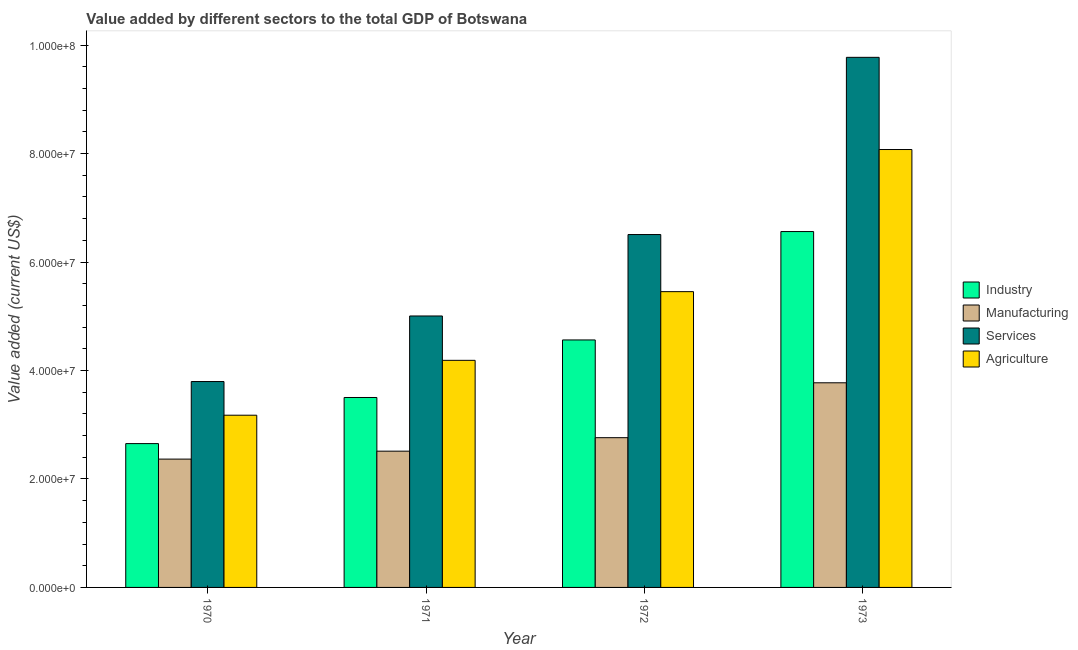How many different coloured bars are there?
Make the answer very short. 4. Are the number of bars on each tick of the X-axis equal?
Give a very brief answer. Yes. What is the label of the 2nd group of bars from the left?
Offer a terse response. 1971. What is the value added by industrial sector in 1972?
Offer a very short reply. 4.56e+07. Across all years, what is the maximum value added by services sector?
Make the answer very short. 9.78e+07. Across all years, what is the minimum value added by services sector?
Your answer should be very brief. 3.80e+07. In which year was the value added by agricultural sector minimum?
Give a very brief answer. 1970. What is the total value added by manufacturing sector in the graph?
Your response must be concise. 1.14e+08. What is the difference between the value added by manufacturing sector in 1971 and that in 1972?
Provide a succinct answer. -2.49e+06. What is the difference between the value added by industrial sector in 1971 and the value added by services sector in 1973?
Ensure brevity in your answer.  -3.06e+07. What is the average value added by agricultural sector per year?
Your answer should be very brief. 5.22e+07. What is the ratio of the value added by agricultural sector in 1971 to that in 1973?
Provide a succinct answer. 0.52. Is the difference between the value added by manufacturing sector in 1972 and 1973 greater than the difference between the value added by services sector in 1972 and 1973?
Your answer should be very brief. No. What is the difference between the highest and the second highest value added by manufacturing sector?
Your answer should be compact. 1.01e+07. What is the difference between the highest and the lowest value added by manufacturing sector?
Provide a succinct answer. 1.41e+07. Is it the case that in every year, the sum of the value added by services sector and value added by manufacturing sector is greater than the sum of value added by industrial sector and value added by agricultural sector?
Provide a short and direct response. Yes. What does the 4th bar from the left in 1972 represents?
Your answer should be compact. Agriculture. What does the 1st bar from the right in 1971 represents?
Give a very brief answer. Agriculture. Is it the case that in every year, the sum of the value added by industrial sector and value added by manufacturing sector is greater than the value added by services sector?
Offer a very short reply. Yes. How many bars are there?
Make the answer very short. 16. Are all the bars in the graph horizontal?
Provide a succinct answer. No. How many years are there in the graph?
Keep it short and to the point. 4. What is the difference between two consecutive major ticks on the Y-axis?
Offer a very short reply. 2.00e+07. Does the graph contain any zero values?
Your answer should be very brief. No. Does the graph contain grids?
Keep it short and to the point. No. How are the legend labels stacked?
Provide a succinct answer. Vertical. What is the title of the graph?
Provide a succinct answer. Value added by different sectors to the total GDP of Botswana. Does "Regional development banks" appear as one of the legend labels in the graph?
Offer a terse response. No. What is the label or title of the Y-axis?
Offer a terse response. Value added (current US$). What is the Value added (current US$) of Industry in 1970?
Provide a short and direct response. 2.65e+07. What is the Value added (current US$) of Manufacturing in 1970?
Offer a very short reply. 2.37e+07. What is the Value added (current US$) in Services in 1970?
Your response must be concise. 3.80e+07. What is the Value added (current US$) of Agriculture in 1970?
Provide a succinct answer. 3.18e+07. What is the Value added (current US$) of Industry in 1971?
Offer a very short reply. 3.50e+07. What is the Value added (current US$) of Manufacturing in 1971?
Provide a succinct answer. 2.51e+07. What is the Value added (current US$) in Services in 1971?
Provide a short and direct response. 5.01e+07. What is the Value added (current US$) in Agriculture in 1971?
Offer a terse response. 4.19e+07. What is the Value added (current US$) of Industry in 1972?
Provide a short and direct response. 4.56e+07. What is the Value added (current US$) in Manufacturing in 1972?
Your answer should be very brief. 2.76e+07. What is the Value added (current US$) of Services in 1972?
Ensure brevity in your answer.  6.51e+07. What is the Value added (current US$) of Agriculture in 1972?
Keep it short and to the point. 5.45e+07. What is the Value added (current US$) of Industry in 1973?
Ensure brevity in your answer.  6.56e+07. What is the Value added (current US$) of Manufacturing in 1973?
Offer a very short reply. 3.77e+07. What is the Value added (current US$) of Services in 1973?
Your answer should be very brief. 9.78e+07. What is the Value added (current US$) in Agriculture in 1973?
Your answer should be very brief. 8.08e+07. Across all years, what is the maximum Value added (current US$) in Industry?
Your answer should be compact. 6.56e+07. Across all years, what is the maximum Value added (current US$) in Manufacturing?
Provide a short and direct response. 3.77e+07. Across all years, what is the maximum Value added (current US$) of Services?
Keep it short and to the point. 9.78e+07. Across all years, what is the maximum Value added (current US$) of Agriculture?
Give a very brief answer. 8.08e+07. Across all years, what is the minimum Value added (current US$) of Industry?
Make the answer very short. 2.65e+07. Across all years, what is the minimum Value added (current US$) of Manufacturing?
Your response must be concise. 2.37e+07. Across all years, what is the minimum Value added (current US$) of Services?
Keep it short and to the point. 3.80e+07. Across all years, what is the minimum Value added (current US$) in Agriculture?
Offer a very short reply. 3.18e+07. What is the total Value added (current US$) in Industry in the graph?
Provide a short and direct response. 1.73e+08. What is the total Value added (current US$) in Manufacturing in the graph?
Your answer should be compact. 1.14e+08. What is the total Value added (current US$) in Services in the graph?
Provide a succinct answer. 2.51e+08. What is the total Value added (current US$) in Agriculture in the graph?
Ensure brevity in your answer.  2.09e+08. What is the difference between the Value added (current US$) in Industry in 1970 and that in 1971?
Your answer should be very brief. -8.50e+06. What is the difference between the Value added (current US$) of Manufacturing in 1970 and that in 1971?
Your answer should be very brief. -1.46e+06. What is the difference between the Value added (current US$) in Services in 1970 and that in 1971?
Give a very brief answer. -1.21e+07. What is the difference between the Value added (current US$) in Agriculture in 1970 and that in 1971?
Provide a succinct answer. -1.01e+07. What is the difference between the Value added (current US$) in Industry in 1970 and that in 1972?
Your response must be concise. -1.91e+07. What is the difference between the Value added (current US$) of Manufacturing in 1970 and that in 1972?
Keep it short and to the point. -3.95e+06. What is the difference between the Value added (current US$) of Services in 1970 and that in 1972?
Offer a very short reply. -2.71e+07. What is the difference between the Value added (current US$) in Agriculture in 1970 and that in 1972?
Your response must be concise. -2.28e+07. What is the difference between the Value added (current US$) in Industry in 1970 and that in 1973?
Your answer should be very brief. -3.91e+07. What is the difference between the Value added (current US$) of Manufacturing in 1970 and that in 1973?
Your response must be concise. -1.41e+07. What is the difference between the Value added (current US$) of Services in 1970 and that in 1973?
Offer a terse response. -5.98e+07. What is the difference between the Value added (current US$) in Agriculture in 1970 and that in 1973?
Your response must be concise. -4.90e+07. What is the difference between the Value added (current US$) in Industry in 1971 and that in 1972?
Your answer should be compact. -1.06e+07. What is the difference between the Value added (current US$) of Manufacturing in 1971 and that in 1972?
Ensure brevity in your answer.  -2.49e+06. What is the difference between the Value added (current US$) of Services in 1971 and that in 1972?
Give a very brief answer. -1.50e+07. What is the difference between the Value added (current US$) of Agriculture in 1971 and that in 1972?
Your response must be concise. -1.27e+07. What is the difference between the Value added (current US$) of Industry in 1971 and that in 1973?
Make the answer very short. -3.06e+07. What is the difference between the Value added (current US$) of Manufacturing in 1971 and that in 1973?
Your answer should be compact. -1.26e+07. What is the difference between the Value added (current US$) in Services in 1971 and that in 1973?
Give a very brief answer. -4.77e+07. What is the difference between the Value added (current US$) of Agriculture in 1971 and that in 1973?
Keep it short and to the point. -3.89e+07. What is the difference between the Value added (current US$) in Industry in 1972 and that in 1973?
Make the answer very short. -2.00e+07. What is the difference between the Value added (current US$) in Manufacturing in 1972 and that in 1973?
Keep it short and to the point. -1.01e+07. What is the difference between the Value added (current US$) in Services in 1972 and that in 1973?
Your answer should be very brief. -3.27e+07. What is the difference between the Value added (current US$) of Agriculture in 1972 and that in 1973?
Your response must be concise. -2.62e+07. What is the difference between the Value added (current US$) of Industry in 1970 and the Value added (current US$) of Manufacturing in 1971?
Ensure brevity in your answer.  1.39e+06. What is the difference between the Value added (current US$) of Industry in 1970 and the Value added (current US$) of Services in 1971?
Give a very brief answer. -2.35e+07. What is the difference between the Value added (current US$) in Industry in 1970 and the Value added (current US$) in Agriculture in 1971?
Your answer should be compact. -1.54e+07. What is the difference between the Value added (current US$) in Manufacturing in 1970 and the Value added (current US$) in Services in 1971?
Your answer should be very brief. -2.64e+07. What is the difference between the Value added (current US$) of Manufacturing in 1970 and the Value added (current US$) of Agriculture in 1971?
Offer a very short reply. -1.82e+07. What is the difference between the Value added (current US$) of Services in 1970 and the Value added (current US$) of Agriculture in 1971?
Provide a short and direct response. -3.91e+06. What is the difference between the Value added (current US$) of Industry in 1970 and the Value added (current US$) of Manufacturing in 1972?
Give a very brief answer. -1.09e+06. What is the difference between the Value added (current US$) of Industry in 1970 and the Value added (current US$) of Services in 1972?
Provide a succinct answer. -3.86e+07. What is the difference between the Value added (current US$) in Industry in 1970 and the Value added (current US$) in Agriculture in 1972?
Provide a succinct answer. -2.80e+07. What is the difference between the Value added (current US$) of Manufacturing in 1970 and the Value added (current US$) of Services in 1972?
Keep it short and to the point. -4.14e+07. What is the difference between the Value added (current US$) of Manufacturing in 1970 and the Value added (current US$) of Agriculture in 1972?
Offer a very short reply. -3.09e+07. What is the difference between the Value added (current US$) of Services in 1970 and the Value added (current US$) of Agriculture in 1972?
Your answer should be very brief. -1.66e+07. What is the difference between the Value added (current US$) of Industry in 1970 and the Value added (current US$) of Manufacturing in 1973?
Ensure brevity in your answer.  -1.12e+07. What is the difference between the Value added (current US$) in Industry in 1970 and the Value added (current US$) in Services in 1973?
Ensure brevity in your answer.  -7.12e+07. What is the difference between the Value added (current US$) of Industry in 1970 and the Value added (current US$) of Agriculture in 1973?
Ensure brevity in your answer.  -5.42e+07. What is the difference between the Value added (current US$) in Manufacturing in 1970 and the Value added (current US$) in Services in 1973?
Your answer should be compact. -7.41e+07. What is the difference between the Value added (current US$) of Manufacturing in 1970 and the Value added (current US$) of Agriculture in 1973?
Give a very brief answer. -5.71e+07. What is the difference between the Value added (current US$) of Services in 1970 and the Value added (current US$) of Agriculture in 1973?
Give a very brief answer. -4.28e+07. What is the difference between the Value added (current US$) of Industry in 1971 and the Value added (current US$) of Manufacturing in 1972?
Offer a very short reply. 7.41e+06. What is the difference between the Value added (current US$) in Industry in 1971 and the Value added (current US$) in Services in 1972?
Provide a succinct answer. -3.00e+07. What is the difference between the Value added (current US$) of Industry in 1971 and the Value added (current US$) of Agriculture in 1972?
Your response must be concise. -1.95e+07. What is the difference between the Value added (current US$) of Manufacturing in 1971 and the Value added (current US$) of Services in 1972?
Make the answer very short. -3.99e+07. What is the difference between the Value added (current US$) of Manufacturing in 1971 and the Value added (current US$) of Agriculture in 1972?
Give a very brief answer. -2.94e+07. What is the difference between the Value added (current US$) in Services in 1971 and the Value added (current US$) in Agriculture in 1972?
Your response must be concise. -4.49e+06. What is the difference between the Value added (current US$) in Industry in 1971 and the Value added (current US$) in Manufacturing in 1973?
Your answer should be very brief. -2.71e+06. What is the difference between the Value added (current US$) in Industry in 1971 and the Value added (current US$) in Services in 1973?
Offer a very short reply. -6.27e+07. What is the difference between the Value added (current US$) of Industry in 1971 and the Value added (current US$) of Agriculture in 1973?
Your answer should be compact. -4.57e+07. What is the difference between the Value added (current US$) of Manufacturing in 1971 and the Value added (current US$) of Services in 1973?
Ensure brevity in your answer.  -7.26e+07. What is the difference between the Value added (current US$) in Manufacturing in 1971 and the Value added (current US$) in Agriculture in 1973?
Your answer should be very brief. -5.56e+07. What is the difference between the Value added (current US$) in Services in 1971 and the Value added (current US$) in Agriculture in 1973?
Provide a succinct answer. -3.07e+07. What is the difference between the Value added (current US$) of Industry in 1972 and the Value added (current US$) of Manufacturing in 1973?
Your answer should be compact. 7.90e+06. What is the difference between the Value added (current US$) in Industry in 1972 and the Value added (current US$) in Services in 1973?
Ensure brevity in your answer.  -5.21e+07. What is the difference between the Value added (current US$) of Industry in 1972 and the Value added (current US$) of Agriculture in 1973?
Give a very brief answer. -3.51e+07. What is the difference between the Value added (current US$) of Manufacturing in 1972 and the Value added (current US$) of Services in 1973?
Make the answer very short. -7.01e+07. What is the difference between the Value added (current US$) in Manufacturing in 1972 and the Value added (current US$) in Agriculture in 1973?
Provide a short and direct response. -5.31e+07. What is the difference between the Value added (current US$) in Services in 1972 and the Value added (current US$) in Agriculture in 1973?
Your answer should be very brief. -1.57e+07. What is the average Value added (current US$) in Industry per year?
Provide a short and direct response. 4.32e+07. What is the average Value added (current US$) in Manufacturing per year?
Make the answer very short. 2.85e+07. What is the average Value added (current US$) of Services per year?
Provide a succinct answer. 6.27e+07. What is the average Value added (current US$) of Agriculture per year?
Keep it short and to the point. 5.22e+07. In the year 1970, what is the difference between the Value added (current US$) in Industry and Value added (current US$) in Manufacturing?
Offer a terse response. 2.86e+06. In the year 1970, what is the difference between the Value added (current US$) in Industry and Value added (current US$) in Services?
Make the answer very short. -1.14e+07. In the year 1970, what is the difference between the Value added (current US$) in Industry and Value added (current US$) in Agriculture?
Provide a succinct answer. -5.23e+06. In the year 1970, what is the difference between the Value added (current US$) in Manufacturing and Value added (current US$) in Services?
Give a very brief answer. -1.43e+07. In the year 1970, what is the difference between the Value added (current US$) in Manufacturing and Value added (current US$) in Agriculture?
Provide a succinct answer. -8.09e+06. In the year 1970, what is the difference between the Value added (current US$) in Services and Value added (current US$) in Agriculture?
Your response must be concise. 6.21e+06. In the year 1971, what is the difference between the Value added (current US$) of Industry and Value added (current US$) of Manufacturing?
Provide a succinct answer. 9.90e+06. In the year 1971, what is the difference between the Value added (current US$) in Industry and Value added (current US$) in Services?
Provide a succinct answer. -1.50e+07. In the year 1971, what is the difference between the Value added (current US$) of Industry and Value added (current US$) of Agriculture?
Your response must be concise. -6.85e+06. In the year 1971, what is the difference between the Value added (current US$) of Manufacturing and Value added (current US$) of Services?
Offer a terse response. -2.49e+07. In the year 1971, what is the difference between the Value added (current US$) of Manufacturing and Value added (current US$) of Agriculture?
Keep it short and to the point. -1.67e+07. In the year 1971, what is the difference between the Value added (current US$) of Services and Value added (current US$) of Agriculture?
Give a very brief answer. 8.18e+06. In the year 1972, what is the difference between the Value added (current US$) of Industry and Value added (current US$) of Manufacturing?
Provide a succinct answer. 1.80e+07. In the year 1972, what is the difference between the Value added (current US$) in Industry and Value added (current US$) in Services?
Your response must be concise. -1.94e+07. In the year 1972, what is the difference between the Value added (current US$) of Industry and Value added (current US$) of Agriculture?
Your answer should be compact. -8.91e+06. In the year 1972, what is the difference between the Value added (current US$) of Manufacturing and Value added (current US$) of Services?
Give a very brief answer. -3.75e+07. In the year 1972, what is the difference between the Value added (current US$) in Manufacturing and Value added (current US$) in Agriculture?
Your answer should be compact. -2.69e+07. In the year 1972, what is the difference between the Value added (current US$) of Services and Value added (current US$) of Agriculture?
Your answer should be compact. 1.05e+07. In the year 1973, what is the difference between the Value added (current US$) of Industry and Value added (current US$) of Manufacturing?
Your response must be concise. 2.79e+07. In the year 1973, what is the difference between the Value added (current US$) of Industry and Value added (current US$) of Services?
Offer a terse response. -3.21e+07. In the year 1973, what is the difference between the Value added (current US$) in Industry and Value added (current US$) in Agriculture?
Ensure brevity in your answer.  -1.51e+07. In the year 1973, what is the difference between the Value added (current US$) of Manufacturing and Value added (current US$) of Services?
Your response must be concise. -6.00e+07. In the year 1973, what is the difference between the Value added (current US$) of Manufacturing and Value added (current US$) of Agriculture?
Keep it short and to the point. -4.30e+07. In the year 1973, what is the difference between the Value added (current US$) in Services and Value added (current US$) in Agriculture?
Offer a terse response. 1.70e+07. What is the ratio of the Value added (current US$) in Industry in 1970 to that in 1971?
Ensure brevity in your answer.  0.76. What is the ratio of the Value added (current US$) of Manufacturing in 1970 to that in 1971?
Make the answer very short. 0.94. What is the ratio of the Value added (current US$) in Services in 1970 to that in 1971?
Offer a terse response. 0.76. What is the ratio of the Value added (current US$) of Agriculture in 1970 to that in 1971?
Give a very brief answer. 0.76. What is the ratio of the Value added (current US$) in Industry in 1970 to that in 1972?
Ensure brevity in your answer.  0.58. What is the ratio of the Value added (current US$) of Manufacturing in 1970 to that in 1972?
Give a very brief answer. 0.86. What is the ratio of the Value added (current US$) in Services in 1970 to that in 1972?
Make the answer very short. 0.58. What is the ratio of the Value added (current US$) of Agriculture in 1970 to that in 1972?
Keep it short and to the point. 0.58. What is the ratio of the Value added (current US$) in Industry in 1970 to that in 1973?
Offer a terse response. 0.4. What is the ratio of the Value added (current US$) in Manufacturing in 1970 to that in 1973?
Make the answer very short. 0.63. What is the ratio of the Value added (current US$) of Services in 1970 to that in 1973?
Provide a short and direct response. 0.39. What is the ratio of the Value added (current US$) of Agriculture in 1970 to that in 1973?
Make the answer very short. 0.39. What is the ratio of the Value added (current US$) of Industry in 1971 to that in 1972?
Keep it short and to the point. 0.77. What is the ratio of the Value added (current US$) of Manufacturing in 1971 to that in 1972?
Your response must be concise. 0.91. What is the ratio of the Value added (current US$) in Services in 1971 to that in 1972?
Keep it short and to the point. 0.77. What is the ratio of the Value added (current US$) of Agriculture in 1971 to that in 1972?
Offer a terse response. 0.77. What is the ratio of the Value added (current US$) of Industry in 1971 to that in 1973?
Ensure brevity in your answer.  0.53. What is the ratio of the Value added (current US$) in Manufacturing in 1971 to that in 1973?
Offer a very short reply. 0.67. What is the ratio of the Value added (current US$) of Services in 1971 to that in 1973?
Provide a short and direct response. 0.51. What is the ratio of the Value added (current US$) in Agriculture in 1971 to that in 1973?
Make the answer very short. 0.52. What is the ratio of the Value added (current US$) of Industry in 1972 to that in 1973?
Your answer should be very brief. 0.7. What is the ratio of the Value added (current US$) in Manufacturing in 1972 to that in 1973?
Make the answer very short. 0.73. What is the ratio of the Value added (current US$) of Services in 1972 to that in 1973?
Your answer should be compact. 0.67. What is the ratio of the Value added (current US$) in Agriculture in 1972 to that in 1973?
Your response must be concise. 0.68. What is the difference between the highest and the second highest Value added (current US$) of Industry?
Offer a very short reply. 2.00e+07. What is the difference between the highest and the second highest Value added (current US$) of Manufacturing?
Keep it short and to the point. 1.01e+07. What is the difference between the highest and the second highest Value added (current US$) in Services?
Keep it short and to the point. 3.27e+07. What is the difference between the highest and the second highest Value added (current US$) in Agriculture?
Your response must be concise. 2.62e+07. What is the difference between the highest and the lowest Value added (current US$) of Industry?
Keep it short and to the point. 3.91e+07. What is the difference between the highest and the lowest Value added (current US$) of Manufacturing?
Your answer should be compact. 1.41e+07. What is the difference between the highest and the lowest Value added (current US$) of Services?
Your answer should be very brief. 5.98e+07. What is the difference between the highest and the lowest Value added (current US$) in Agriculture?
Your response must be concise. 4.90e+07. 